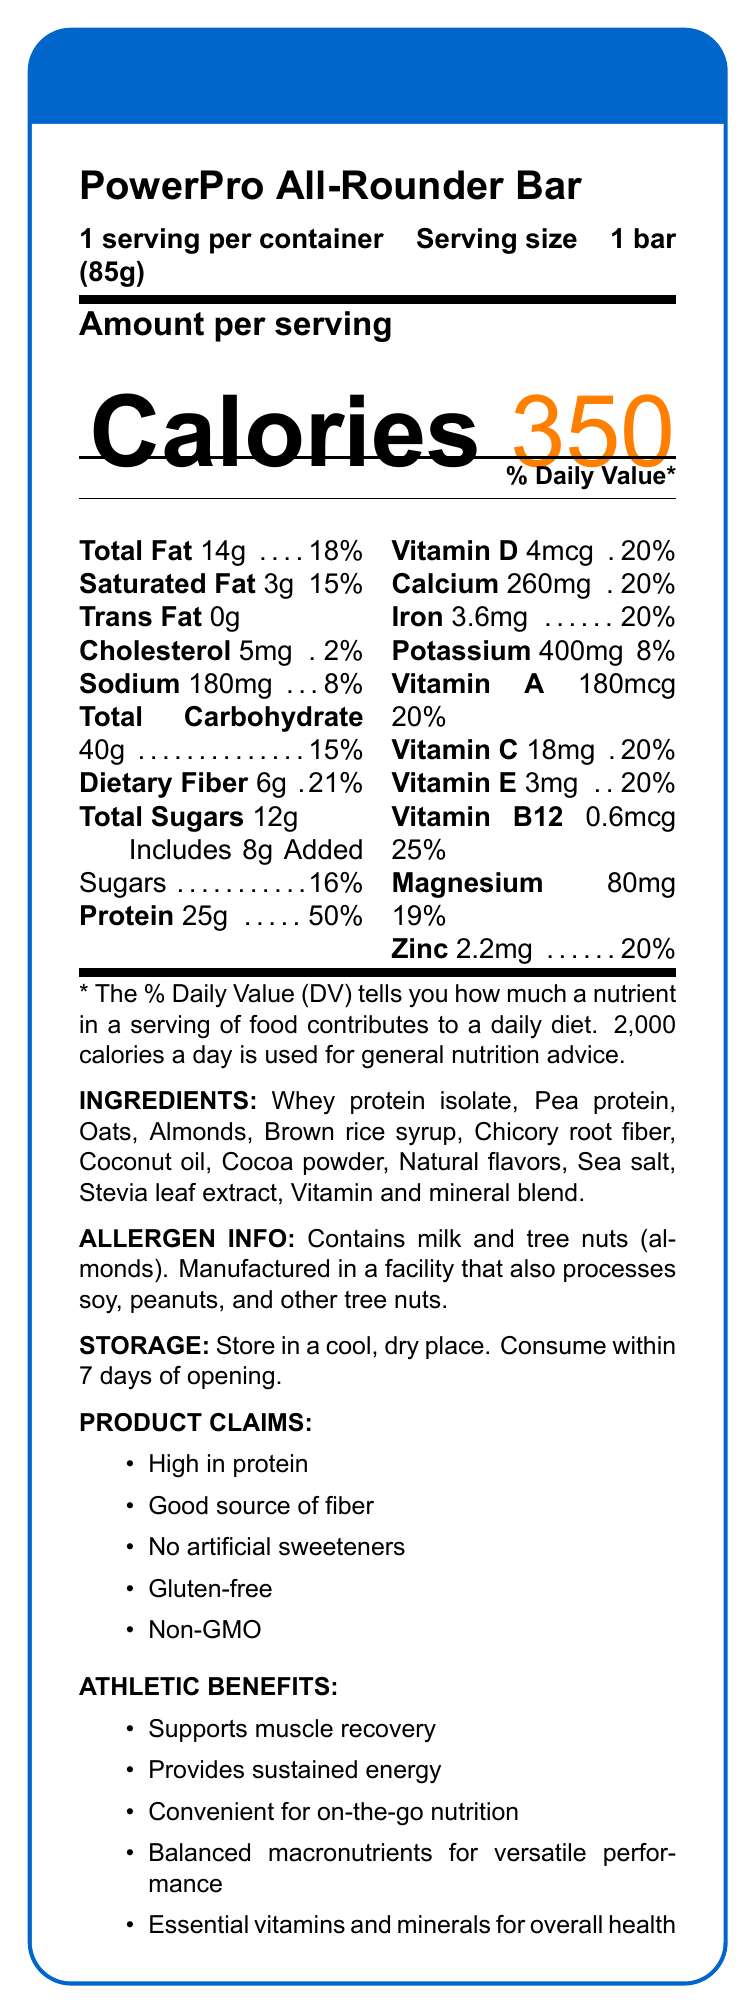What is the serving size of the PowerPro All-Rounder Bar? The document clearly states that the serving size for the PowerPro All-Rounder Bar is 1 bar (85g).
Answer: 1 bar (85g) How many calories are in one serving of the PowerPro All-Rounder Bar? The document shows that one serving of the PowerPro All-Rounder Bar contains 350 calories.
Answer: 350 What is the % daily value of dietary fiber per serving? According to the document, the % daily value of dietary fiber per serving is 21%.
Answer: 21% How much protein does the PowerPro All-Rounder Bar provide per serving? The document indicates that each bar provides 25g of protein.
Answer: 25g What are the storage instructions for the PowerPro All-Rounder Bar? The document specifies to store the bar in a cool, dry place and consume it within 7 days of opening.
Answer: Store in a cool, dry place. Consume within 7 days of opening. Which nutrient in the PowerPro All-Rounder Bar has the highest % daily value? The document shows protein has the highest % daily value at 50%.
Answer: Protein What are the allergen information details for the PowerPro All-Rounder Bar? The document provides allergen information, mentioning that the product contains milk and tree nuts (almonds) and is manufactured in a facility that also processes soy, peanuts, and other tree nuts.
Answer: Contains milk and tree nuts (almonds). Manufactured in a facility that also processes soy, peanuts, and other tree nuts. What benefits does the PowerPro All-Rounder Bar offer for athletes? (Select all that apply) A. Supports muscle recovery B. Provides sustained energy C. Good source of antioxidants D. Convenient for on-the-go nutrition The athletic benefits listed in the document include supporting muscle recovery, providing sustained energy, and being convenient for on-the-go nutrition.
Answer: A, B, D Which vitamin has the lowest % daily value in the PowerPro All-Rounder Bar? A. Vitamin A B. Vitamin E C. Vitamin B12 D. Vitamin D The document shows Vitamin B12 has a % daily value of 25%, which is the lowest among the listed vitamins.
Answer: C Does the PowerPro All-Rounder Bar contain any artificial sweeteners? Yes or No The document mentions that the product has no artificial sweeteners, as indicated in the product claims.
Answer: No Summarize the main nutritional highlights and benefits of the PowerPro All-Rounder Bar. A detailed review of the document shows it focuses on the nutritional content and athletic benefits of the PowerPro All-Rounder Bar.
Answer: The PowerPro All-Rounder Bar is a nutrient-dense meal replacement bar designed for busy athletes on-the-go, offering 350 calories per bar. It is high in protein (25g, 50% DV), a good source of fiber (21% DV), and includes essential vitamins and minerals. The bar also contains 14g of total fat and 40g of total carbohydrates. It supports muscle recovery, provides sustained energy, and offers convenience with balanced macronutrients for versatile performance. How much sugar is present in the PowerPro All-Rounder Bar? The document states there are 12g of total sugars, which includes 8g of added sugars.
Answer: 12g total sugars, includes 8g added sugars What is the main protein source in the PowerPro All-Rounder Bar? The document lists whey protein isolate as the first ingredient, making it the main protein source.
Answer: Whey protein isolate Is the PowerPro All-Rounder Bar gluten-free? The document claims that the PowerPro All-Rounder Bar is gluten-free.
Answer: Yes Can the document tell us the exact expiration date of the PowerPro All-Rounder Bar? The document provides storage instructions but does not include information about the expiration date.
Answer: Not enough information 